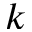<formula> <loc_0><loc_0><loc_500><loc_500>k</formula> 